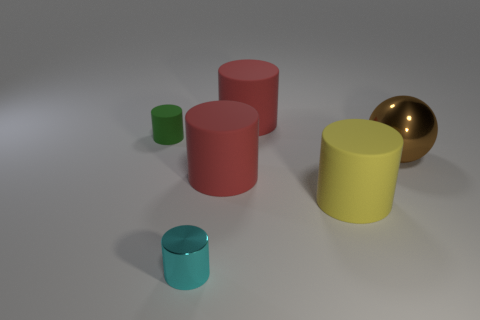What number of other big shiny objects are the same shape as the large yellow object?
Offer a very short reply. 0. There is a green cylinder; is its size the same as the red matte thing in front of the shiny ball?
Keep it short and to the point. No. What is the shape of the shiny thing that is right of the red cylinder that is behind the tiny rubber cylinder?
Provide a short and direct response. Sphere. Are there fewer big red matte cylinders that are on the right side of the yellow thing than things?
Offer a terse response. Yes. How many rubber cylinders have the same size as the brown ball?
Your answer should be very brief. 3. What shape is the shiny object that is behind the tiny cyan cylinder?
Make the answer very short. Sphere. Are there fewer cyan rubber cubes than brown balls?
Your answer should be compact. Yes. Are there any other things of the same color as the small rubber cylinder?
Keep it short and to the point. No. What size is the green cylinder behind the big metallic sphere?
Offer a very short reply. Small. Are there more yellow rubber things than brown matte spheres?
Give a very brief answer. Yes. 